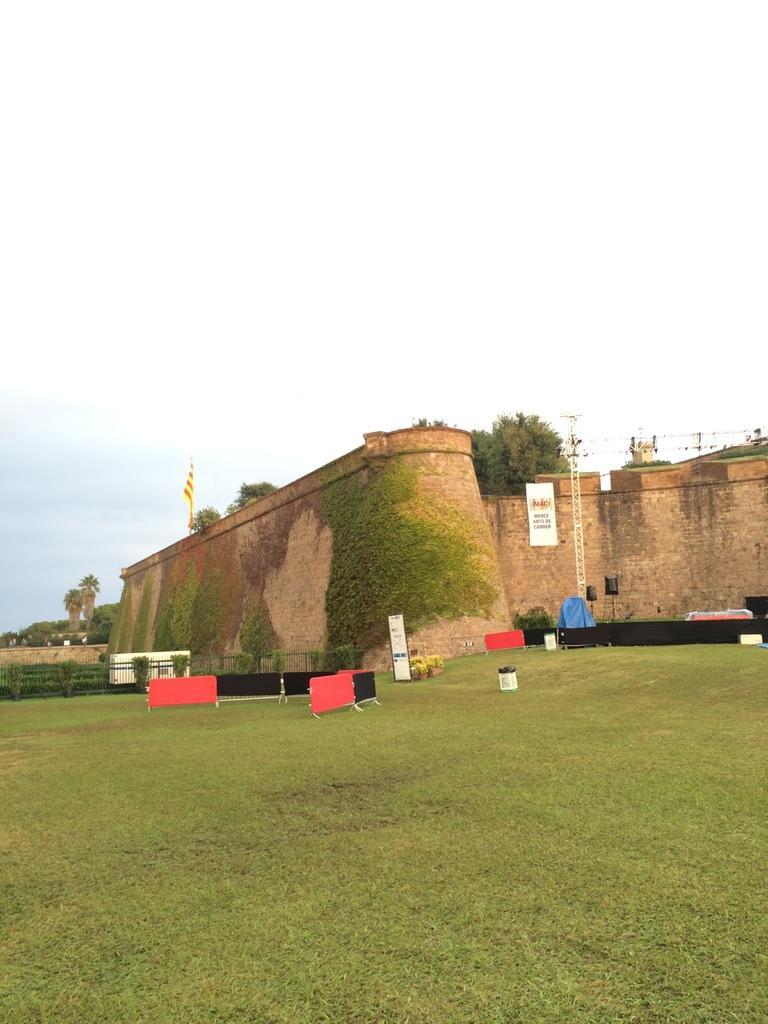Can you describe this image briefly? In this image we can see a fortification, there are trees, there is a grass, there is a fencing, there is a white board, there is a sky. 